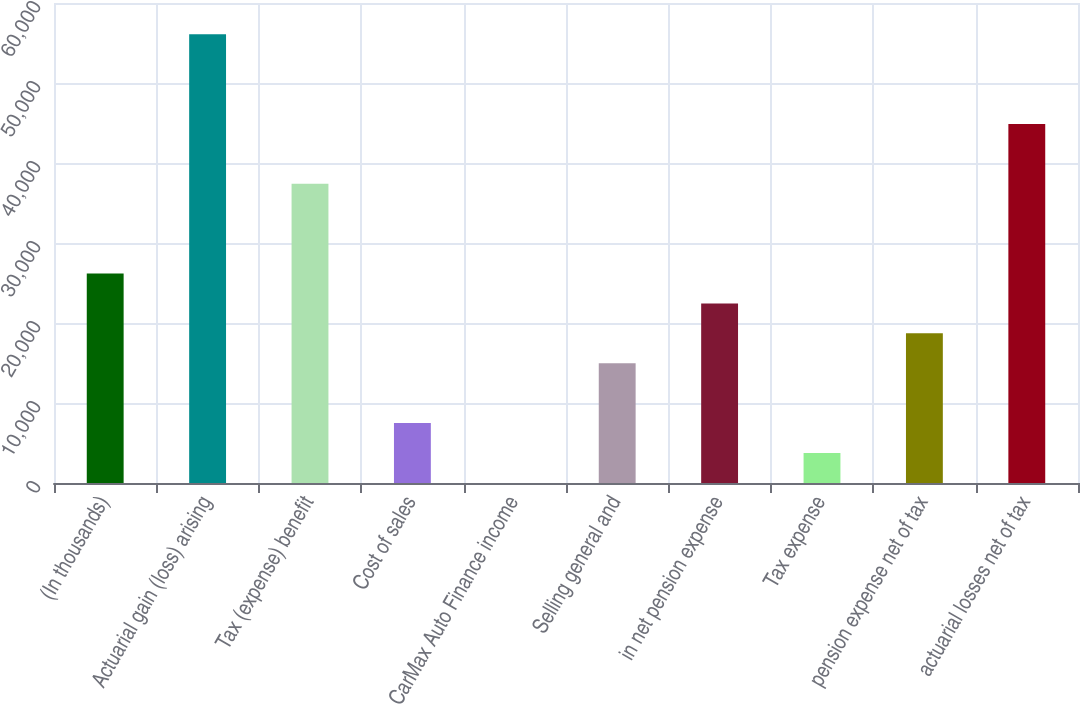<chart> <loc_0><loc_0><loc_500><loc_500><bar_chart><fcel>(In thousands)<fcel>Actuarial gain (loss) arising<fcel>Tax (expense) benefit<fcel>Cost of sales<fcel>CarMax Auto Finance income<fcel>Selling general and<fcel>in net pension expense<fcel>Tax expense<fcel>pension expense net of tax<fcel>actuarial losses net of tax<nl><fcel>26185<fcel>56097<fcel>37402<fcel>7490<fcel>12<fcel>14968<fcel>22446<fcel>3751<fcel>18707<fcel>44880<nl></chart> 